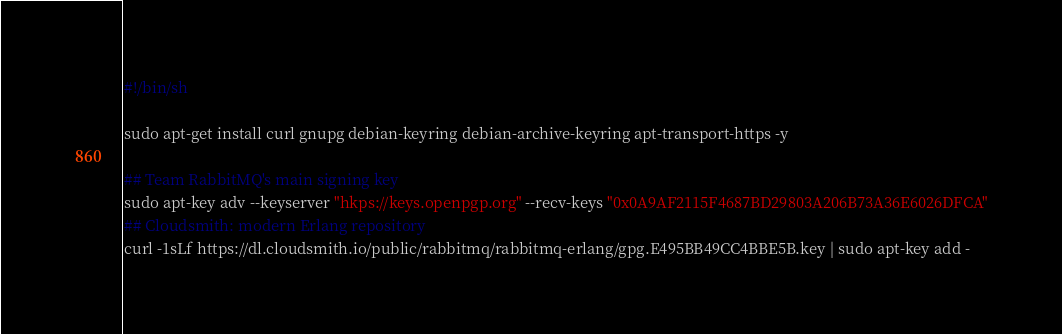Convert code to text. <code><loc_0><loc_0><loc_500><loc_500><_Bash_>#!/bin/sh

sudo apt-get install curl gnupg debian-keyring debian-archive-keyring apt-transport-https -y

## Team RabbitMQ's main signing key
sudo apt-key adv --keyserver "hkps://keys.openpgp.org" --recv-keys "0x0A9AF2115F4687BD29803A206B73A36E6026DFCA"
## Cloudsmith: modern Erlang repository
curl -1sLf https://dl.cloudsmith.io/public/rabbitmq/rabbitmq-erlang/gpg.E495BB49CC4BBE5B.key | sudo apt-key add -</code> 